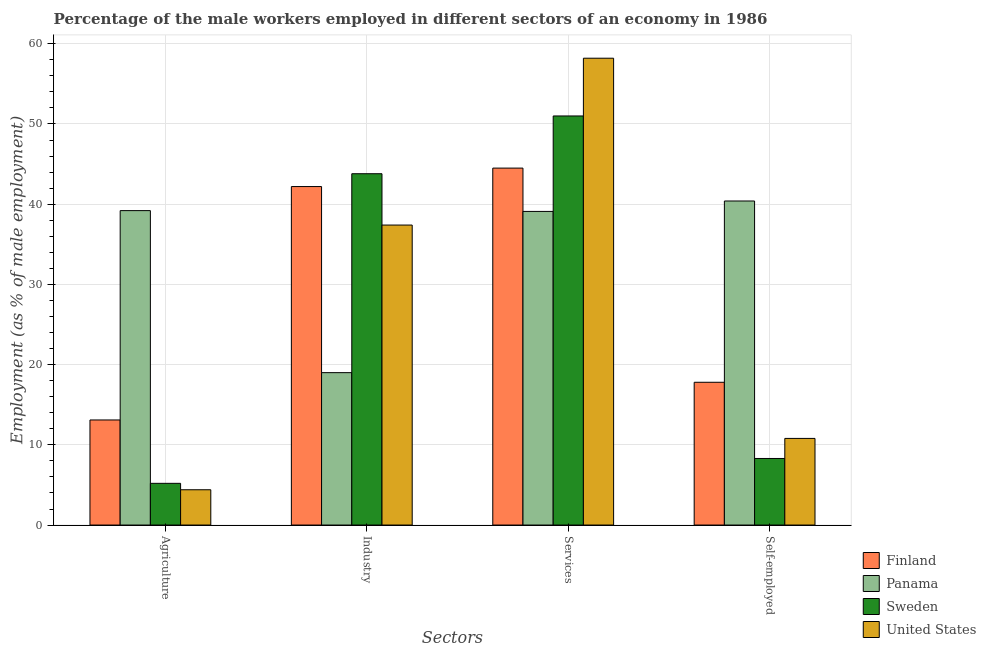How many different coloured bars are there?
Your answer should be compact. 4. How many groups of bars are there?
Provide a short and direct response. 4. Are the number of bars per tick equal to the number of legend labels?
Your answer should be compact. Yes. Are the number of bars on each tick of the X-axis equal?
Your response must be concise. Yes. How many bars are there on the 2nd tick from the left?
Keep it short and to the point. 4. How many bars are there on the 3rd tick from the right?
Keep it short and to the point. 4. What is the label of the 2nd group of bars from the left?
Your answer should be very brief. Industry. What is the percentage of male workers in industry in United States?
Offer a terse response. 37.4. Across all countries, what is the maximum percentage of male workers in industry?
Keep it short and to the point. 43.8. Across all countries, what is the minimum percentage of male workers in agriculture?
Your answer should be very brief. 4.4. In which country was the percentage of male workers in services maximum?
Offer a very short reply. United States. In which country was the percentage of male workers in industry minimum?
Your answer should be compact. Panama. What is the total percentage of self employed male workers in the graph?
Your answer should be compact. 77.3. What is the difference between the percentage of male workers in services in Sweden and that in Panama?
Your answer should be very brief. 11.9. What is the difference between the percentage of male workers in services in Finland and the percentage of self employed male workers in Panama?
Provide a short and direct response. 4.1. What is the average percentage of male workers in industry per country?
Give a very brief answer. 35.6. What is the difference between the percentage of male workers in agriculture and percentage of male workers in services in Panama?
Give a very brief answer. 0.1. In how many countries, is the percentage of self employed male workers greater than 58 %?
Keep it short and to the point. 0. What is the ratio of the percentage of male workers in agriculture in Panama to that in Sweden?
Offer a very short reply. 7.54. Is the difference between the percentage of male workers in services in United States and Finland greater than the difference between the percentage of male workers in agriculture in United States and Finland?
Give a very brief answer. Yes. What is the difference between the highest and the second highest percentage of male workers in services?
Provide a succinct answer. 7.2. What is the difference between the highest and the lowest percentage of male workers in services?
Ensure brevity in your answer.  19.1. In how many countries, is the percentage of male workers in agriculture greater than the average percentage of male workers in agriculture taken over all countries?
Offer a terse response. 1. Is it the case that in every country, the sum of the percentage of male workers in services and percentage of male workers in agriculture is greater than the sum of percentage of self employed male workers and percentage of male workers in industry?
Ensure brevity in your answer.  Yes. What does the 3rd bar from the right in Agriculture represents?
Make the answer very short. Panama. How many countries are there in the graph?
Provide a succinct answer. 4. Are the values on the major ticks of Y-axis written in scientific E-notation?
Give a very brief answer. No. Does the graph contain grids?
Ensure brevity in your answer.  Yes. What is the title of the graph?
Your response must be concise. Percentage of the male workers employed in different sectors of an economy in 1986. What is the label or title of the X-axis?
Give a very brief answer. Sectors. What is the label or title of the Y-axis?
Keep it short and to the point. Employment (as % of male employment). What is the Employment (as % of male employment) of Finland in Agriculture?
Offer a terse response. 13.1. What is the Employment (as % of male employment) in Panama in Agriculture?
Provide a short and direct response. 39.2. What is the Employment (as % of male employment) of Sweden in Agriculture?
Make the answer very short. 5.2. What is the Employment (as % of male employment) of United States in Agriculture?
Keep it short and to the point. 4.4. What is the Employment (as % of male employment) in Finland in Industry?
Your response must be concise. 42.2. What is the Employment (as % of male employment) of Sweden in Industry?
Provide a succinct answer. 43.8. What is the Employment (as % of male employment) of United States in Industry?
Your response must be concise. 37.4. What is the Employment (as % of male employment) of Finland in Services?
Make the answer very short. 44.5. What is the Employment (as % of male employment) in Panama in Services?
Ensure brevity in your answer.  39.1. What is the Employment (as % of male employment) in United States in Services?
Ensure brevity in your answer.  58.2. What is the Employment (as % of male employment) in Finland in Self-employed?
Provide a succinct answer. 17.8. What is the Employment (as % of male employment) of Panama in Self-employed?
Your answer should be very brief. 40.4. What is the Employment (as % of male employment) in Sweden in Self-employed?
Provide a short and direct response. 8.3. What is the Employment (as % of male employment) in United States in Self-employed?
Offer a terse response. 10.8. Across all Sectors, what is the maximum Employment (as % of male employment) in Finland?
Your answer should be very brief. 44.5. Across all Sectors, what is the maximum Employment (as % of male employment) in Panama?
Your answer should be compact. 40.4. Across all Sectors, what is the maximum Employment (as % of male employment) of Sweden?
Ensure brevity in your answer.  51. Across all Sectors, what is the maximum Employment (as % of male employment) in United States?
Provide a succinct answer. 58.2. Across all Sectors, what is the minimum Employment (as % of male employment) of Finland?
Give a very brief answer. 13.1. Across all Sectors, what is the minimum Employment (as % of male employment) of Sweden?
Give a very brief answer. 5.2. Across all Sectors, what is the minimum Employment (as % of male employment) in United States?
Your answer should be compact. 4.4. What is the total Employment (as % of male employment) of Finland in the graph?
Provide a short and direct response. 117.6. What is the total Employment (as % of male employment) in Panama in the graph?
Provide a short and direct response. 137.7. What is the total Employment (as % of male employment) of Sweden in the graph?
Provide a succinct answer. 108.3. What is the total Employment (as % of male employment) in United States in the graph?
Your response must be concise. 110.8. What is the difference between the Employment (as % of male employment) of Finland in Agriculture and that in Industry?
Provide a succinct answer. -29.1. What is the difference between the Employment (as % of male employment) in Panama in Agriculture and that in Industry?
Offer a very short reply. 20.2. What is the difference between the Employment (as % of male employment) in Sweden in Agriculture and that in Industry?
Make the answer very short. -38.6. What is the difference between the Employment (as % of male employment) in United States in Agriculture and that in Industry?
Give a very brief answer. -33. What is the difference between the Employment (as % of male employment) in Finland in Agriculture and that in Services?
Make the answer very short. -31.4. What is the difference between the Employment (as % of male employment) of Panama in Agriculture and that in Services?
Keep it short and to the point. 0.1. What is the difference between the Employment (as % of male employment) in Sweden in Agriculture and that in Services?
Make the answer very short. -45.8. What is the difference between the Employment (as % of male employment) of United States in Agriculture and that in Services?
Your response must be concise. -53.8. What is the difference between the Employment (as % of male employment) in Finland in Agriculture and that in Self-employed?
Give a very brief answer. -4.7. What is the difference between the Employment (as % of male employment) in Panama in Agriculture and that in Self-employed?
Offer a terse response. -1.2. What is the difference between the Employment (as % of male employment) in Sweden in Agriculture and that in Self-employed?
Provide a short and direct response. -3.1. What is the difference between the Employment (as % of male employment) in Panama in Industry and that in Services?
Ensure brevity in your answer.  -20.1. What is the difference between the Employment (as % of male employment) in Sweden in Industry and that in Services?
Make the answer very short. -7.2. What is the difference between the Employment (as % of male employment) in United States in Industry and that in Services?
Your response must be concise. -20.8. What is the difference between the Employment (as % of male employment) in Finland in Industry and that in Self-employed?
Offer a very short reply. 24.4. What is the difference between the Employment (as % of male employment) in Panama in Industry and that in Self-employed?
Your answer should be very brief. -21.4. What is the difference between the Employment (as % of male employment) of Sweden in Industry and that in Self-employed?
Provide a short and direct response. 35.5. What is the difference between the Employment (as % of male employment) in United States in Industry and that in Self-employed?
Ensure brevity in your answer.  26.6. What is the difference between the Employment (as % of male employment) of Finland in Services and that in Self-employed?
Make the answer very short. 26.7. What is the difference between the Employment (as % of male employment) in Panama in Services and that in Self-employed?
Offer a very short reply. -1.3. What is the difference between the Employment (as % of male employment) in Sweden in Services and that in Self-employed?
Your answer should be compact. 42.7. What is the difference between the Employment (as % of male employment) of United States in Services and that in Self-employed?
Offer a very short reply. 47.4. What is the difference between the Employment (as % of male employment) of Finland in Agriculture and the Employment (as % of male employment) of Sweden in Industry?
Provide a short and direct response. -30.7. What is the difference between the Employment (as % of male employment) of Finland in Agriculture and the Employment (as % of male employment) of United States in Industry?
Your answer should be compact. -24.3. What is the difference between the Employment (as % of male employment) of Sweden in Agriculture and the Employment (as % of male employment) of United States in Industry?
Give a very brief answer. -32.2. What is the difference between the Employment (as % of male employment) in Finland in Agriculture and the Employment (as % of male employment) in Panama in Services?
Make the answer very short. -26. What is the difference between the Employment (as % of male employment) of Finland in Agriculture and the Employment (as % of male employment) of Sweden in Services?
Ensure brevity in your answer.  -37.9. What is the difference between the Employment (as % of male employment) in Finland in Agriculture and the Employment (as % of male employment) in United States in Services?
Ensure brevity in your answer.  -45.1. What is the difference between the Employment (as % of male employment) of Panama in Agriculture and the Employment (as % of male employment) of Sweden in Services?
Offer a terse response. -11.8. What is the difference between the Employment (as % of male employment) of Panama in Agriculture and the Employment (as % of male employment) of United States in Services?
Make the answer very short. -19. What is the difference between the Employment (as % of male employment) in Sweden in Agriculture and the Employment (as % of male employment) in United States in Services?
Your answer should be compact. -53. What is the difference between the Employment (as % of male employment) in Finland in Agriculture and the Employment (as % of male employment) in Panama in Self-employed?
Keep it short and to the point. -27.3. What is the difference between the Employment (as % of male employment) in Finland in Agriculture and the Employment (as % of male employment) in United States in Self-employed?
Offer a terse response. 2.3. What is the difference between the Employment (as % of male employment) of Panama in Agriculture and the Employment (as % of male employment) of Sweden in Self-employed?
Keep it short and to the point. 30.9. What is the difference between the Employment (as % of male employment) of Panama in Agriculture and the Employment (as % of male employment) of United States in Self-employed?
Provide a short and direct response. 28.4. What is the difference between the Employment (as % of male employment) in Finland in Industry and the Employment (as % of male employment) in Sweden in Services?
Keep it short and to the point. -8.8. What is the difference between the Employment (as % of male employment) of Finland in Industry and the Employment (as % of male employment) of United States in Services?
Your answer should be compact. -16. What is the difference between the Employment (as % of male employment) of Panama in Industry and the Employment (as % of male employment) of Sweden in Services?
Offer a very short reply. -32. What is the difference between the Employment (as % of male employment) of Panama in Industry and the Employment (as % of male employment) of United States in Services?
Provide a short and direct response. -39.2. What is the difference between the Employment (as % of male employment) of Sweden in Industry and the Employment (as % of male employment) of United States in Services?
Offer a very short reply. -14.4. What is the difference between the Employment (as % of male employment) in Finland in Industry and the Employment (as % of male employment) in Panama in Self-employed?
Ensure brevity in your answer.  1.8. What is the difference between the Employment (as % of male employment) of Finland in Industry and the Employment (as % of male employment) of Sweden in Self-employed?
Provide a short and direct response. 33.9. What is the difference between the Employment (as % of male employment) of Finland in Industry and the Employment (as % of male employment) of United States in Self-employed?
Your response must be concise. 31.4. What is the difference between the Employment (as % of male employment) in Finland in Services and the Employment (as % of male employment) in Sweden in Self-employed?
Make the answer very short. 36.2. What is the difference between the Employment (as % of male employment) in Finland in Services and the Employment (as % of male employment) in United States in Self-employed?
Your answer should be compact. 33.7. What is the difference between the Employment (as % of male employment) in Panama in Services and the Employment (as % of male employment) in Sweden in Self-employed?
Provide a short and direct response. 30.8. What is the difference between the Employment (as % of male employment) in Panama in Services and the Employment (as % of male employment) in United States in Self-employed?
Offer a very short reply. 28.3. What is the difference between the Employment (as % of male employment) in Sweden in Services and the Employment (as % of male employment) in United States in Self-employed?
Your answer should be compact. 40.2. What is the average Employment (as % of male employment) of Finland per Sectors?
Keep it short and to the point. 29.4. What is the average Employment (as % of male employment) in Panama per Sectors?
Your answer should be very brief. 34.42. What is the average Employment (as % of male employment) of Sweden per Sectors?
Keep it short and to the point. 27.07. What is the average Employment (as % of male employment) in United States per Sectors?
Your answer should be compact. 27.7. What is the difference between the Employment (as % of male employment) of Finland and Employment (as % of male employment) of Panama in Agriculture?
Give a very brief answer. -26.1. What is the difference between the Employment (as % of male employment) in Panama and Employment (as % of male employment) in Sweden in Agriculture?
Offer a terse response. 34. What is the difference between the Employment (as % of male employment) in Panama and Employment (as % of male employment) in United States in Agriculture?
Give a very brief answer. 34.8. What is the difference between the Employment (as % of male employment) of Finland and Employment (as % of male employment) of Panama in Industry?
Your answer should be very brief. 23.2. What is the difference between the Employment (as % of male employment) in Panama and Employment (as % of male employment) in Sweden in Industry?
Offer a very short reply. -24.8. What is the difference between the Employment (as % of male employment) in Panama and Employment (as % of male employment) in United States in Industry?
Keep it short and to the point. -18.4. What is the difference between the Employment (as % of male employment) of Finland and Employment (as % of male employment) of Panama in Services?
Offer a very short reply. 5.4. What is the difference between the Employment (as % of male employment) in Finland and Employment (as % of male employment) in Sweden in Services?
Provide a short and direct response. -6.5. What is the difference between the Employment (as % of male employment) of Finland and Employment (as % of male employment) of United States in Services?
Make the answer very short. -13.7. What is the difference between the Employment (as % of male employment) in Panama and Employment (as % of male employment) in Sweden in Services?
Provide a succinct answer. -11.9. What is the difference between the Employment (as % of male employment) in Panama and Employment (as % of male employment) in United States in Services?
Keep it short and to the point. -19.1. What is the difference between the Employment (as % of male employment) in Finland and Employment (as % of male employment) in Panama in Self-employed?
Your answer should be very brief. -22.6. What is the difference between the Employment (as % of male employment) of Panama and Employment (as % of male employment) of Sweden in Self-employed?
Your answer should be very brief. 32.1. What is the difference between the Employment (as % of male employment) in Panama and Employment (as % of male employment) in United States in Self-employed?
Your answer should be very brief. 29.6. What is the ratio of the Employment (as % of male employment) of Finland in Agriculture to that in Industry?
Your response must be concise. 0.31. What is the ratio of the Employment (as % of male employment) of Panama in Agriculture to that in Industry?
Provide a succinct answer. 2.06. What is the ratio of the Employment (as % of male employment) of Sweden in Agriculture to that in Industry?
Provide a short and direct response. 0.12. What is the ratio of the Employment (as % of male employment) of United States in Agriculture to that in Industry?
Keep it short and to the point. 0.12. What is the ratio of the Employment (as % of male employment) in Finland in Agriculture to that in Services?
Provide a succinct answer. 0.29. What is the ratio of the Employment (as % of male employment) in Panama in Agriculture to that in Services?
Keep it short and to the point. 1. What is the ratio of the Employment (as % of male employment) of Sweden in Agriculture to that in Services?
Ensure brevity in your answer.  0.1. What is the ratio of the Employment (as % of male employment) of United States in Agriculture to that in Services?
Your answer should be very brief. 0.08. What is the ratio of the Employment (as % of male employment) in Finland in Agriculture to that in Self-employed?
Offer a very short reply. 0.74. What is the ratio of the Employment (as % of male employment) of Panama in Agriculture to that in Self-employed?
Offer a terse response. 0.97. What is the ratio of the Employment (as % of male employment) of Sweden in Agriculture to that in Self-employed?
Your answer should be very brief. 0.63. What is the ratio of the Employment (as % of male employment) of United States in Agriculture to that in Self-employed?
Your answer should be compact. 0.41. What is the ratio of the Employment (as % of male employment) of Finland in Industry to that in Services?
Keep it short and to the point. 0.95. What is the ratio of the Employment (as % of male employment) of Panama in Industry to that in Services?
Ensure brevity in your answer.  0.49. What is the ratio of the Employment (as % of male employment) in Sweden in Industry to that in Services?
Give a very brief answer. 0.86. What is the ratio of the Employment (as % of male employment) of United States in Industry to that in Services?
Your answer should be compact. 0.64. What is the ratio of the Employment (as % of male employment) in Finland in Industry to that in Self-employed?
Your answer should be compact. 2.37. What is the ratio of the Employment (as % of male employment) in Panama in Industry to that in Self-employed?
Offer a very short reply. 0.47. What is the ratio of the Employment (as % of male employment) of Sweden in Industry to that in Self-employed?
Provide a succinct answer. 5.28. What is the ratio of the Employment (as % of male employment) of United States in Industry to that in Self-employed?
Your answer should be very brief. 3.46. What is the ratio of the Employment (as % of male employment) in Panama in Services to that in Self-employed?
Give a very brief answer. 0.97. What is the ratio of the Employment (as % of male employment) of Sweden in Services to that in Self-employed?
Your answer should be very brief. 6.14. What is the ratio of the Employment (as % of male employment) in United States in Services to that in Self-employed?
Give a very brief answer. 5.39. What is the difference between the highest and the second highest Employment (as % of male employment) in Panama?
Ensure brevity in your answer.  1.2. What is the difference between the highest and the second highest Employment (as % of male employment) in United States?
Provide a short and direct response. 20.8. What is the difference between the highest and the lowest Employment (as % of male employment) of Finland?
Offer a terse response. 31.4. What is the difference between the highest and the lowest Employment (as % of male employment) of Panama?
Ensure brevity in your answer.  21.4. What is the difference between the highest and the lowest Employment (as % of male employment) in Sweden?
Provide a succinct answer. 45.8. What is the difference between the highest and the lowest Employment (as % of male employment) of United States?
Your answer should be compact. 53.8. 